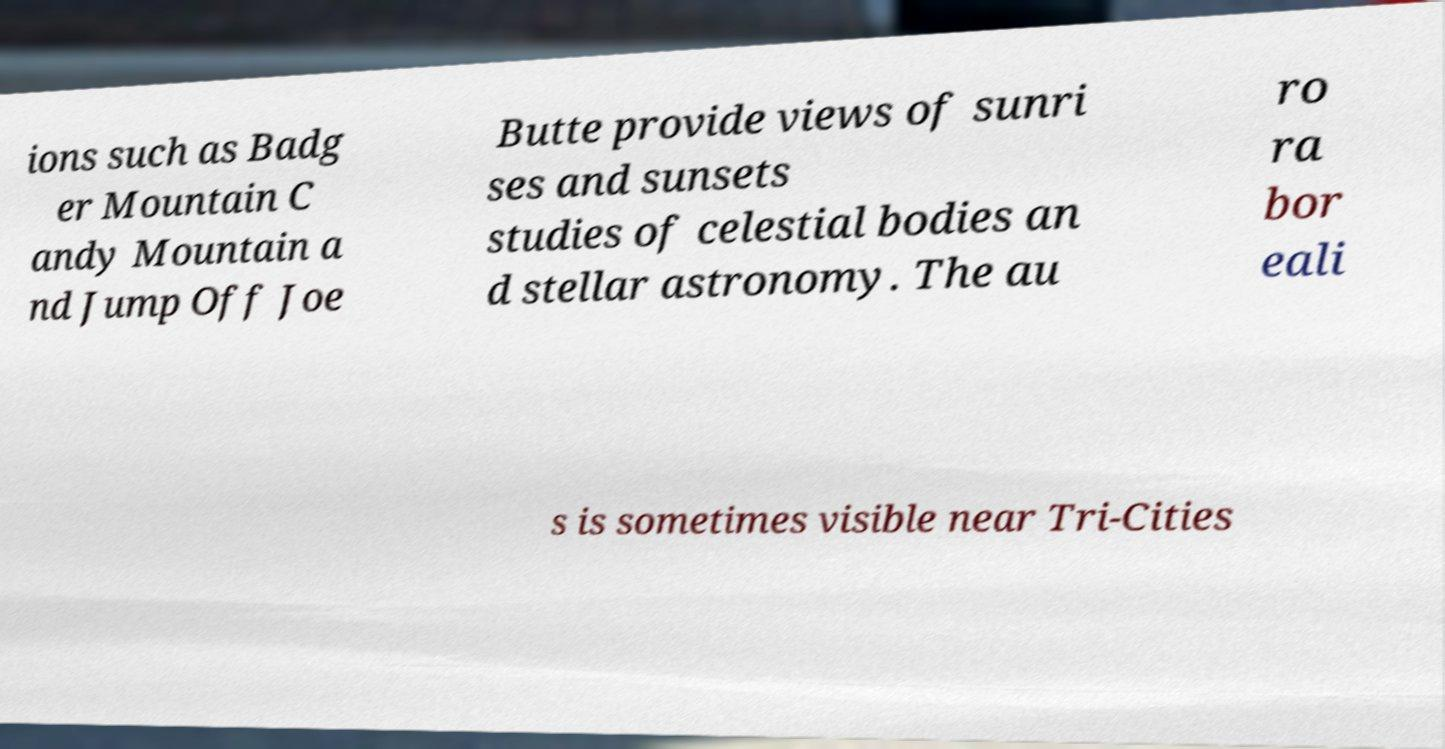I need the written content from this picture converted into text. Can you do that? ions such as Badg er Mountain C andy Mountain a nd Jump Off Joe Butte provide views of sunri ses and sunsets studies of celestial bodies an d stellar astronomy. The au ro ra bor eali s is sometimes visible near Tri-Cities 